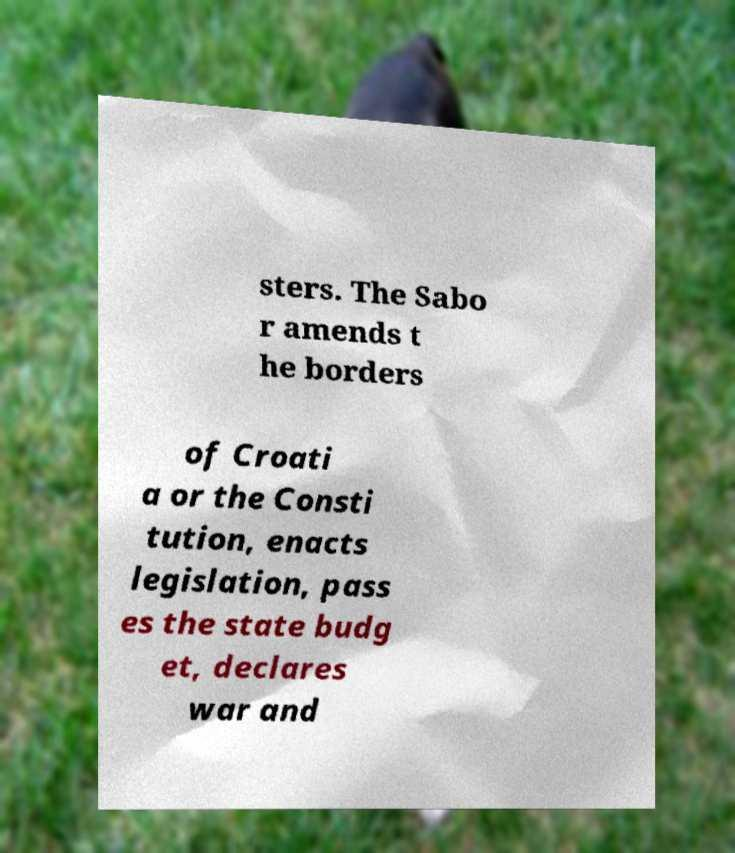Please identify and transcribe the text found in this image. sters. The Sabo r amends t he borders of Croati a or the Consti tution, enacts legislation, pass es the state budg et, declares war and 